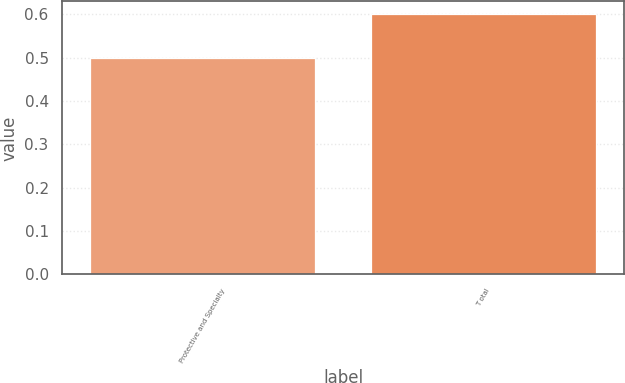Convert chart to OTSL. <chart><loc_0><loc_0><loc_500><loc_500><bar_chart><fcel>Protective and Specialty<fcel>T otal<nl><fcel>0.5<fcel>0.6<nl></chart> 